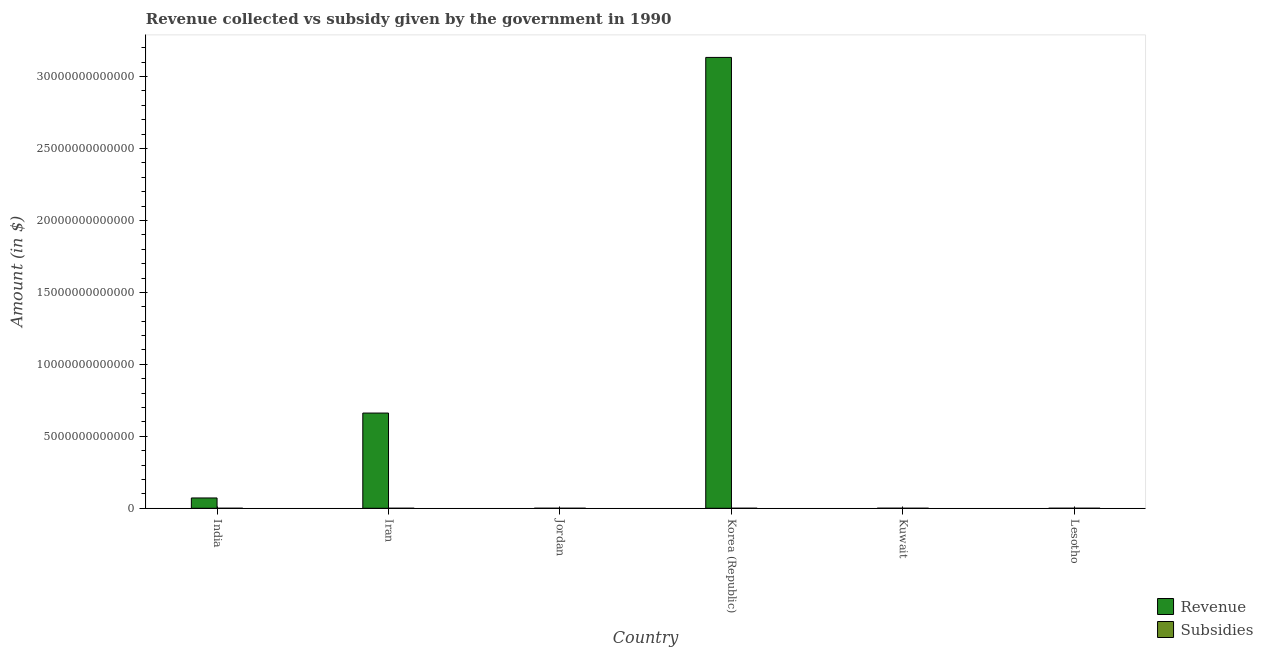How many groups of bars are there?
Make the answer very short. 6. Are the number of bars on each tick of the X-axis equal?
Your answer should be compact. Yes. How many bars are there on the 6th tick from the left?
Offer a terse response. 2. What is the amount of subsidies given in Kuwait?
Provide a succinct answer. 1.88e+08. Across all countries, what is the maximum amount of revenue collected?
Provide a short and direct response. 3.13e+13. Across all countries, what is the minimum amount of revenue collected?
Offer a terse response. 6.28e+08. In which country was the amount of revenue collected minimum?
Give a very brief answer. Lesotho. What is the total amount of revenue collected in the graph?
Provide a short and direct response. 3.87e+13. What is the difference between the amount of revenue collected in Iran and that in Korea (Republic)?
Give a very brief answer. -2.47e+13. What is the difference between the amount of revenue collected in Lesotho and the amount of subsidies given in Korea (Republic)?
Your answer should be compact. 2.98e+08. What is the average amount of subsidies given per country?
Provide a short and direct response. 1.84e+08. What is the difference between the amount of revenue collected and amount of subsidies given in India?
Offer a very short reply. 7.16e+11. In how many countries, is the amount of revenue collected greater than 1000000000000 $?
Provide a succinct answer. 2. What is the ratio of the amount of revenue collected in India to that in Jordan?
Give a very brief answer. 1026.26. What is the difference between the highest and the second highest amount of revenue collected?
Your answer should be compact. 2.47e+13. What is the difference between the highest and the lowest amount of revenue collected?
Ensure brevity in your answer.  3.13e+13. In how many countries, is the amount of revenue collected greater than the average amount of revenue collected taken over all countries?
Ensure brevity in your answer.  2. What does the 1st bar from the left in India represents?
Offer a terse response. Revenue. What does the 2nd bar from the right in Korea (Republic) represents?
Offer a very short reply. Revenue. How many bars are there?
Provide a short and direct response. 12. Are all the bars in the graph horizontal?
Your response must be concise. No. What is the difference between two consecutive major ticks on the Y-axis?
Offer a terse response. 5.00e+12. Are the values on the major ticks of Y-axis written in scientific E-notation?
Your answer should be compact. No. Does the graph contain grids?
Offer a very short reply. No. How many legend labels are there?
Give a very brief answer. 2. How are the legend labels stacked?
Your response must be concise. Vertical. What is the title of the graph?
Give a very brief answer. Revenue collected vs subsidy given by the government in 1990. What is the label or title of the X-axis?
Provide a succinct answer. Country. What is the label or title of the Y-axis?
Ensure brevity in your answer.  Amount (in $). What is the Amount (in $) of Revenue in India?
Keep it short and to the point. 7.16e+11. What is the Amount (in $) of Subsidies in India?
Keep it short and to the point. 1.81e+08. What is the Amount (in $) in Revenue in Iran?
Make the answer very short. 6.62e+12. What is the Amount (in $) of Subsidies in Iran?
Make the answer very short. 1.29e+07. What is the Amount (in $) of Revenue in Jordan?
Give a very brief answer. 6.98e+08. What is the Amount (in $) of Subsidies in Jordan?
Make the answer very short. 8.38e+07. What is the Amount (in $) in Revenue in Korea (Republic)?
Provide a succinct answer. 3.13e+13. What is the Amount (in $) in Subsidies in Korea (Republic)?
Your response must be concise. 3.30e+08. What is the Amount (in $) in Revenue in Kuwait?
Offer a very short reply. 3.12e+09. What is the Amount (in $) in Subsidies in Kuwait?
Make the answer very short. 1.88e+08. What is the Amount (in $) of Revenue in Lesotho?
Offer a very short reply. 6.28e+08. What is the Amount (in $) in Subsidies in Lesotho?
Provide a short and direct response. 3.07e+08. Across all countries, what is the maximum Amount (in $) of Revenue?
Make the answer very short. 3.13e+13. Across all countries, what is the maximum Amount (in $) in Subsidies?
Ensure brevity in your answer.  3.30e+08. Across all countries, what is the minimum Amount (in $) of Revenue?
Offer a very short reply. 6.28e+08. Across all countries, what is the minimum Amount (in $) of Subsidies?
Your answer should be very brief. 1.29e+07. What is the total Amount (in $) of Revenue in the graph?
Your response must be concise. 3.87e+13. What is the total Amount (in $) of Subsidies in the graph?
Your answer should be compact. 1.10e+09. What is the difference between the Amount (in $) of Revenue in India and that in Iran?
Keep it short and to the point. -5.90e+12. What is the difference between the Amount (in $) in Subsidies in India and that in Iran?
Give a very brief answer. 1.69e+08. What is the difference between the Amount (in $) of Revenue in India and that in Jordan?
Give a very brief answer. 7.15e+11. What is the difference between the Amount (in $) of Subsidies in India and that in Jordan?
Provide a short and direct response. 9.76e+07. What is the difference between the Amount (in $) in Revenue in India and that in Korea (Republic)?
Your answer should be very brief. -3.06e+13. What is the difference between the Amount (in $) in Subsidies in India and that in Korea (Republic)?
Provide a succinct answer. -1.48e+08. What is the difference between the Amount (in $) in Revenue in India and that in Kuwait?
Give a very brief answer. 7.13e+11. What is the difference between the Amount (in $) of Subsidies in India and that in Kuwait?
Provide a succinct answer. -6.48e+06. What is the difference between the Amount (in $) of Revenue in India and that in Lesotho?
Your answer should be compact. 7.15e+11. What is the difference between the Amount (in $) in Subsidies in India and that in Lesotho?
Keep it short and to the point. -1.26e+08. What is the difference between the Amount (in $) of Revenue in Iran and that in Jordan?
Offer a terse response. 6.62e+12. What is the difference between the Amount (in $) of Subsidies in Iran and that in Jordan?
Provide a short and direct response. -7.09e+07. What is the difference between the Amount (in $) of Revenue in Iran and that in Korea (Republic)?
Provide a succinct answer. -2.47e+13. What is the difference between the Amount (in $) of Subsidies in Iran and that in Korea (Republic)?
Keep it short and to the point. -3.17e+08. What is the difference between the Amount (in $) of Revenue in Iran and that in Kuwait?
Your response must be concise. 6.61e+12. What is the difference between the Amount (in $) in Subsidies in Iran and that in Kuwait?
Make the answer very short. -1.75e+08. What is the difference between the Amount (in $) of Revenue in Iran and that in Lesotho?
Give a very brief answer. 6.62e+12. What is the difference between the Amount (in $) of Subsidies in Iran and that in Lesotho?
Give a very brief answer. -2.94e+08. What is the difference between the Amount (in $) in Revenue in Jordan and that in Korea (Republic)?
Provide a succinct answer. -3.13e+13. What is the difference between the Amount (in $) of Subsidies in Jordan and that in Korea (Republic)?
Your answer should be compact. -2.46e+08. What is the difference between the Amount (in $) of Revenue in Jordan and that in Kuwait?
Ensure brevity in your answer.  -2.42e+09. What is the difference between the Amount (in $) of Subsidies in Jordan and that in Kuwait?
Give a very brief answer. -1.04e+08. What is the difference between the Amount (in $) of Revenue in Jordan and that in Lesotho?
Ensure brevity in your answer.  7.00e+07. What is the difference between the Amount (in $) in Subsidies in Jordan and that in Lesotho?
Provide a short and direct response. -2.23e+08. What is the difference between the Amount (in $) of Revenue in Korea (Republic) and that in Kuwait?
Offer a terse response. 3.13e+13. What is the difference between the Amount (in $) of Subsidies in Korea (Republic) and that in Kuwait?
Offer a very short reply. 1.42e+08. What is the difference between the Amount (in $) in Revenue in Korea (Republic) and that in Lesotho?
Make the answer very short. 3.13e+13. What is the difference between the Amount (in $) in Subsidies in Korea (Republic) and that in Lesotho?
Make the answer very short. 2.25e+07. What is the difference between the Amount (in $) in Revenue in Kuwait and that in Lesotho?
Your answer should be very brief. 2.49e+09. What is the difference between the Amount (in $) of Subsidies in Kuwait and that in Lesotho?
Provide a short and direct response. -1.19e+08. What is the difference between the Amount (in $) of Revenue in India and the Amount (in $) of Subsidies in Iran?
Offer a very short reply. 7.16e+11. What is the difference between the Amount (in $) in Revenue in India and the Amount (in $) in Subsidies in Jordan?
Provide a short and direct response. 7.16e+11. What is the difference between the Amount (in $) in Revenue in India and the Amount (in $) in Subsidies in Korea (Republic)?
Your answer should be very brief. 7.16e+11. What is the difference between the Amount (in $) of Revenue in India and the Amount (in $) of Subsidies in Kuwait?
Your answer should be very brief. 7.16e+11. What is the difference between the Amount (in $) in Revenue in India and the Amount (in $) in Subsidies in Lesotho?
Offer a terse response. 7.16e+11. What is the difference between the Amount (in $) of Revenue in Iran and the Amount (in $) of Subsidies in Jordan?
Make the answer very short. 6.62e+12. What is the difference between the Amount (in $) in Revenue in Iran and the Amount (in $) in Subsidies in Korea (Republic)?
Provide a short and direct response. 6.62e+12. What is the difference between the Amount (in $) in Revenue in Iran and the Amount (in $) in Subsidies in Kuwait?
Keep it short and to the point. 6.62e+12. What is the difference between the Amount (in $) in Revenue in Iran and the Amount (in $) in Subsidies in Lesotho?
Provide a succinct answer. 6.62e+12. What is the difference between the Amount (in $) of Revenue in Jordan and the Amount (in $) of Subsidies in Korea (Republic)?
Your response must be concise. 3.68e+08. What is the difference between the Amount (in $) of Revenue in Jordan and the Amount (in $) of Subsidies in Kuwait?
Offer a terse response. 5.10e+08. What is the difference between the Amount (in $) in Revenue in Jordan and the Amount (in $) in Subsidies in Lesotho?
Ensure brevity in your answer.  3.90e+08. What is the difference between the Amount (in $) in Revenue in Korea (Republic) and the Amount (in $) in Subsidies in Kuwait?
Provide a short and direct response. 3.13e+13. What is the difference between the Amount (in $) of Revenue in Korea (Republic) and the Amount (in $) of Subsidies in Lesotho?
Offer a terse response. 3.13e+13. What is the difference between the Amount (in $) in Revenue in Kuwait and the Amount (in $) in Subsidies in Lesotho?
Provide a short and direct response. 2.81e+09. What is the average Amount (in $) in Revenue per country?
Provide a succinct answer. 6.44e+12. What is the average Amount (in $) of Subsidies per country?
Give a very brief answer. 1.84e+08. What is the difference between the Amount (in $) in Revenue and Amount (in $) in Subsidies in India?
Your answer should be very brief. 7.16e+11. What is the difference between the Amount (in $) in Revenue and Amount (in $) in Subsidies in Iran?
Your answer should be very brief. 6.62e+12. What is the difference between the Amount (in $) of Revenue and Amount (in $) of Subsidies in Jordan?
Offer a very short reply. 6.14e+08. What is the difference between the Amount (in $) of Revenue and Amount (in $) of Subsidies in Korea (Republic)?
Offer a terse response. 3.13e+13. What is the difference between the Amount (in $) in Revenue and Amount (in $) in Subsidies in Kuwait?
Ensure brevity in your answer.  2.93e+09. What is the difference between the Amount (in $) of Revenue and Amount (in $) of Subsidies in Lesotho?
Your answer should be very brief. 3.20e+08. What is the ratio of the Amount (in $) in Revenue in India to that in Iran?
Provide a succinct answer. 0.11. What is the ratio of the Amount (in $) in Subsidies in India to that in Iran?
Keep it short and to the point. 14.08. What is the ratio of the Amount (in $) of Revenue in India to that in Jordan?
Keep it short and to the point. 1026.26. What is the ratio of the Amount (in $) of Subsidies in India to that in Jordan?
Your answer should be compact. 2.16. What is the ratio of the Amount (in $) in Revenue in India to that in Korea (Republic)?
Give a very brief answer. 0.02. What is the ratio of the Amount (in $) in Subsidies in India to that in Korea (Republic)?
Your response must be concise. 0.55. What is the ratio of the Amount (in $) in Revenue in India to that in Kuwait?
Offer a terse response. 229.74. What is the ratio of the Amount (in $) in Subsidies in India to that in Kuwait?
Your answer should be very brief. 0.97. What is the ratio of the Amount (in $) of Revenue in India to that in Lesotho?
Offer a terse response. 1140.71. What is the ratio of the Amount (in $) in Subsidies in India to that in Lesotho?
Make the answer very short. 0.59. What is the ratio of the Amount (in $) of Revenue in Iran to that in Jordan?
Offer a very short reply. 9486.06. What is the ratio of the Amount (in $) of Subsidies in Iran to that in Jordan?
Make the answer very short. 0.15. What is the ratio of the Amount (in $) in Revenue in Iran to that in Korea (Republic)?
Your answer should be compact. 0.21. What is the ratio of the Amount (in $) in Subsidies in Iran to that in Korea (Republic)?
Give a very brief answer. 0.04. What is the ratio of the Amount (in $) of Revenue in Iran to that in Kuwait?
Give a very brief answer. 2123.56. What is the ratio of the Amount (in $) of Subsidies in Iran to that in Kuwait?
Offer a very short reply. 0.07. What is the ratio of the Amount (in $) in Revenue in Iran to that in Lesotho?
Make the answer very short. 1.05e+04. What is the ratio of the Amount (in $) of Subsidies in Iran to that in Lesotho?
Make the answer very short. 0.04. What is the ratio of the Amount (in $) in Subsidies in Jordan to that in Korea (Republic)?
Ensure brevity in your answer.  0.25. What is the ratio of the Amount (in $) of Revenue in Jordan to that in Kuwait?
Make the answer very short. 0.22. What is the ratio of the Amount (in $) of Subsidies in Jordan to that in Kuwait?
Your answer should be very brief. 0.45. What is the ratio of the Amount (in $) of Revenue in Jordan to that in Lesotho?
Your response must be concise. 1.11. What is the ratio of the Amount (in $) in Subsidies in Jordan to that in Lesotho?
Offer a very short reply. 0.27. What is the ratio of the Amount (in $) in Revenue in Korea (Republic) to that in Kuwait?
Provide a succinct answer. 1.01e+04. What is the ratio of the Amount (in $) of Subsidies in Korea (Republic) to that in Kuwait?
Give a very brief answer. 1.75. What is the ratio of the Amount (in $) of Revenue in Korea (Republic) to that in Lesotho?
Your answer should be very brief. 4.99e+04. What is the ratio of the Amount (in $) of Subsidies in Korea (Republic) to that in Lesotho?
Your answer should be very brief. 1.07. What is the ratio of the Amount (in $) of Revenue in Kuwait to that in Lesotho?
Provide a short and direct response. 4.97. What is the ratio of the Amount (in $) in Subsidies in Kuwait to that in Lesotho?
Make the answer very short. 0.61. What is the difference between the highest and the second highest Amount (in $) of Revenue?
Your answer should be very brief. 2.47e+13. What is the difference between the highest and the second highest Amount (in $) of Subsidies?
Provide a short and direct response. 2.25e+07. What is the difference between the highest and the lowest Amount (in $) in Revenue?
Offer a terse response. 3.13e+13. What is the difference between the highest and the lowest Amount (in $) in Subsidies?
Offer a terse response. 3.17e+08. 